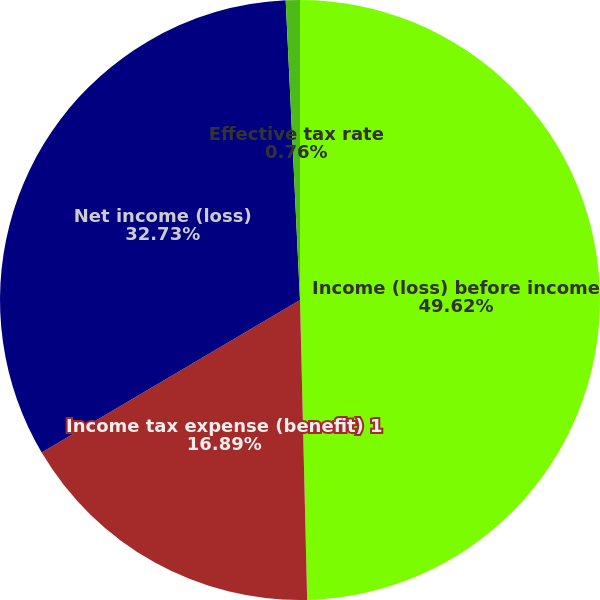<chart> <loc_0><loc_0><loc_500><loc_500><pie_chart><fcel>Income (loss) before income<fcel>Income tax expense (benefit) 1<fcel>Net income (loss)<fcel>Effective tax rate<nl><fcel>49.62%<fcel>16.89%<fcel>32.73%<fcel>0.76%<nl></chart> 